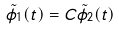Convert formula to latex. <formula><loc_0><loc_0><loc_500><loc_500>\tilde { \phi } _ { 1 } ( t ) = C \tilde { \phi } _ { 2 } ( t )</formula> 